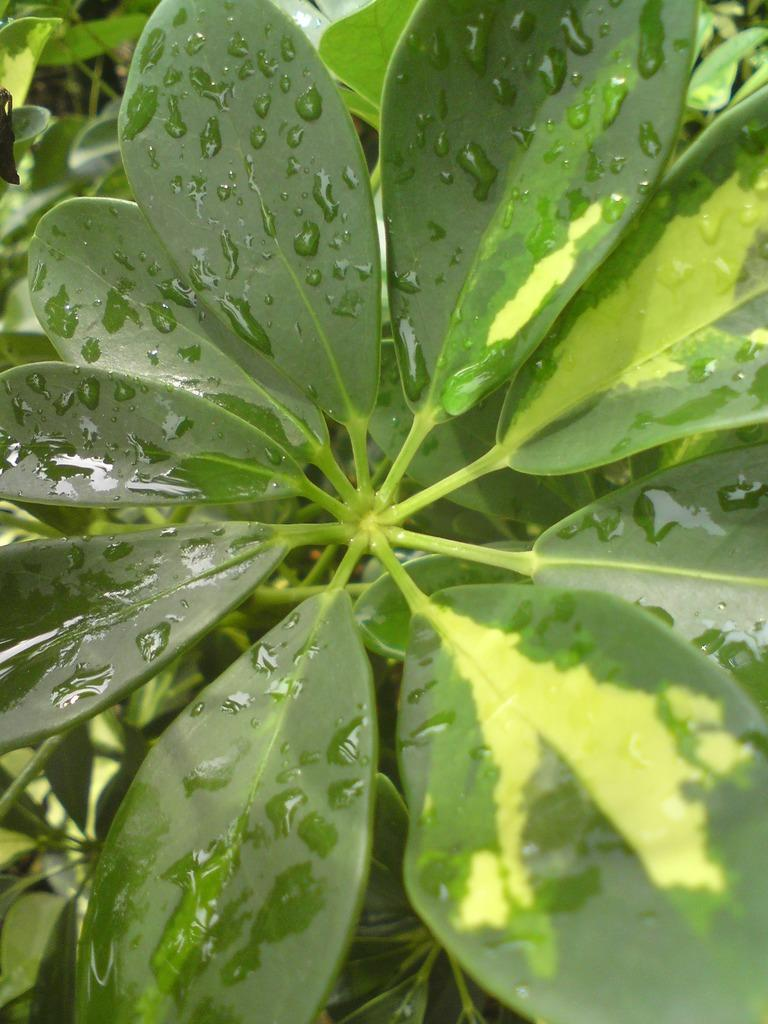What type of plant material is present in the image? The image contains leaves and stems. Can you describe the condition of the leaves in the image? There are water droplets on the leaves in the image. What can be seen in the background of the image? There is greenery in the background of the image. What type of advertisement is being displayed on the hand in the image? There is no hand or advertisement present in the image. 